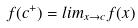Convert formula to latex. <formula><loc_0><loc_0><loc_500><loc_500>f ( c ^ { + } ) = l i m _ { x \rightarrow c } f ( x )</formula> 